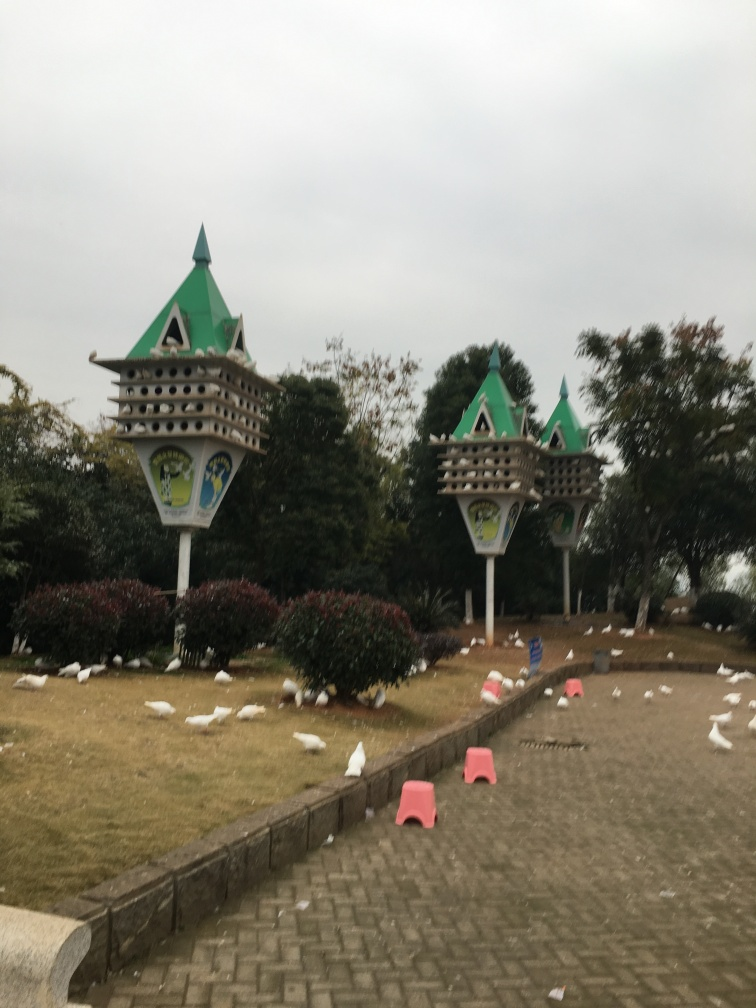What is the weather like in this picture? The sky appears overcast, suggesting a cloudy day without direct sunlight, which might indicate a cooler temperature as well. Does that affect the mood of the image? Yes, the overcast sky can create a more subdued and calm atmosphere, potentially evoking a sense of tranquility or reflection. 